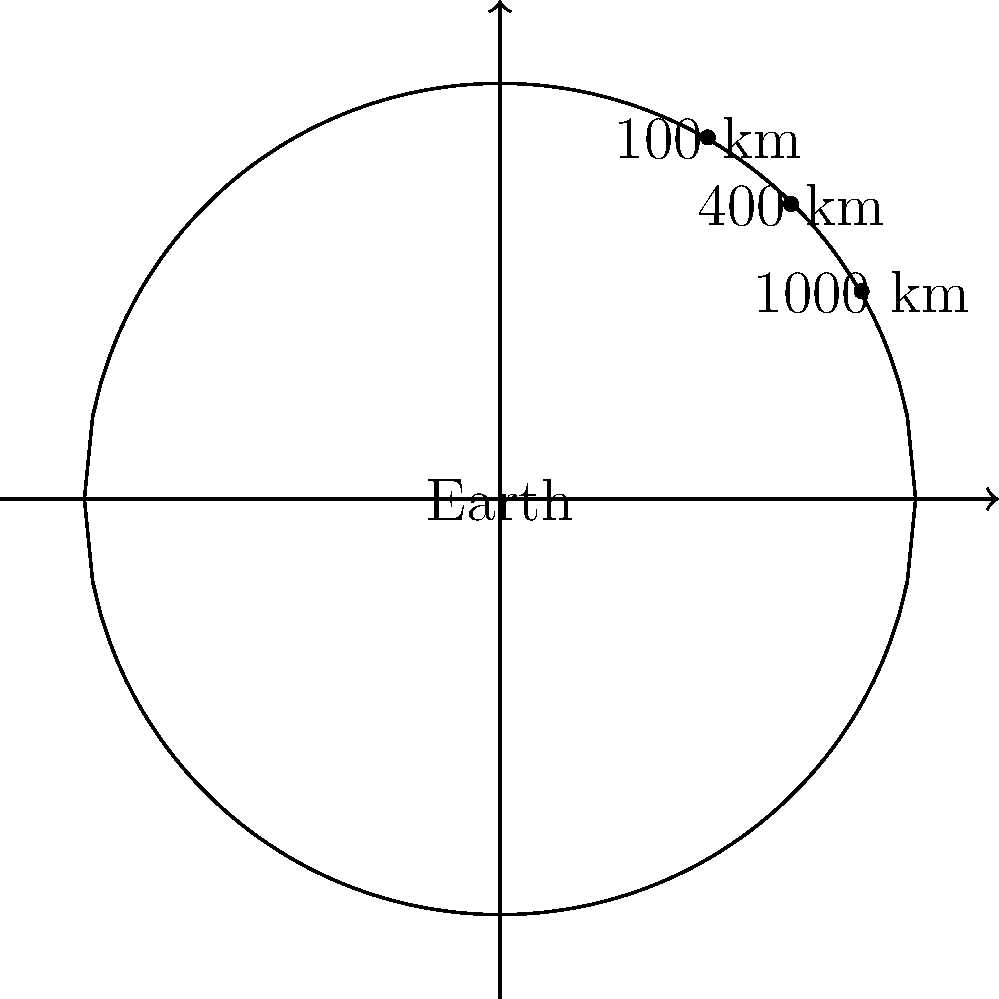As you ascend from Earth's surface to different altitudes in space, how does the visible portion of Earth's surface area change? Consider the following altitudes: 100 km (edge of space), 400 km (ISS orbit), and 1000 km. What mathematical relationship best describes this change? To understand how the visible portion of Earth's surface area changes with altitude, we need to follow these steps:

1. Recall that Earth is approximately spherical with a radius (R) of about 6,371 km.

2. The visible portion of Earth from a given altitude forms a spherical cap.

3. The formula for the area of a spherical cap is:
   $A = 2\pi R h$
   where $h$ is the height of the cap.

4. To find $h$, we use the Pythagorean theorem:
   $(R + d)^2 = R^2 + (R - h)^2$
   where $d$ is the altitude above Earth's surface.

5. Solving for $h$:
   $h = R - \sqrt{R^2 - 2Rd - d^2}$

6. Substituting this into the area formula:
   $A = 2\pi R (R - \sqrt{R^2 - 2Rd - d^2})$

7. Calculate the visible area for each altitude:
   - 100 km: $A \approx 31.5$ million km²
   - 400 km: $A \approx 124.7$ million km²
   - 1000 km: $A \approx 304.3$ million km²

8. Observe that as altitude increases, the visible area increases, but not linearly.

9. The relationship between altitude and visible area follows a square root function, as evident from the formula derived in step 6.
Answer: Square root relationship 